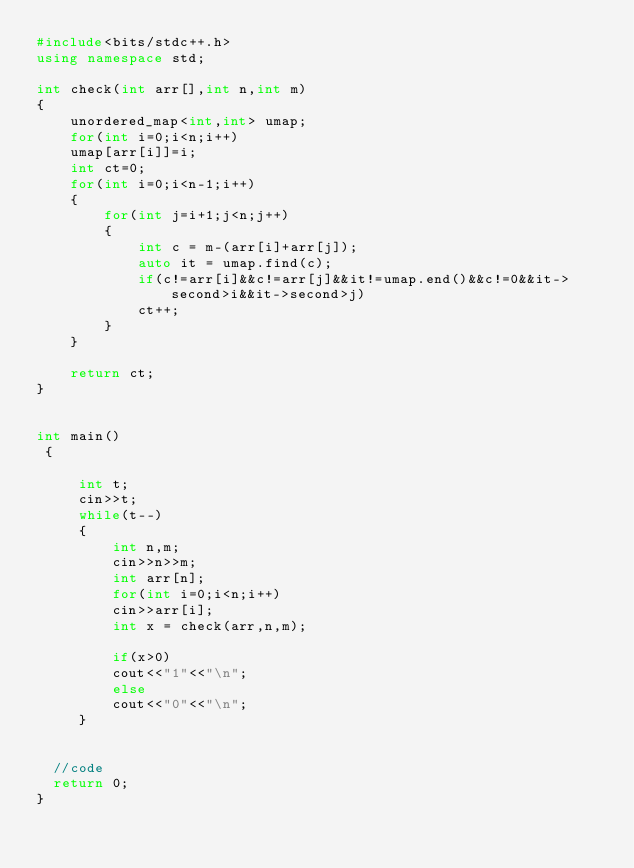Convert code to text. <code><loc_0><loc_0><loc_500><loc_500><_C++_>#include<bits/stdc++.h>
using namespace std;

int check(int arr[],int n,int m)
{
    unordered_map<int,int> umap;
    for(int i=0;i<n;i++)
    umap[arr[i]]=i;
    int ct=0;
    for(int i=0;i<n-1;i++)
    {
        for(int j=i+1;j<n;j++)
        {
            int c = m-(arr[i]+arr[j]);
            auto it = umap.find(c);
            if(c!=arr[i]&&c!=arr[j]&&it!=umap.end()&&c!=0&&it->second>i&&it->second>j)
            ct++;
        }
    }
    
    return ct;
}


int main()
 {
     
     int t;
     cin>>t;
     while(t--)
     {
         int n,m;
         cin>>n>>m;
         int arr[n];
         for(int i=0;i<n;i++)
         cin>>arr[i];
         int x = check(arr,n,m);
         
         if(x>0)
         cout<<"1"<<"\n";
         else
         cout<<"0"<<"\n";
     }
     
     
	//code
	return 0;
}</code> 